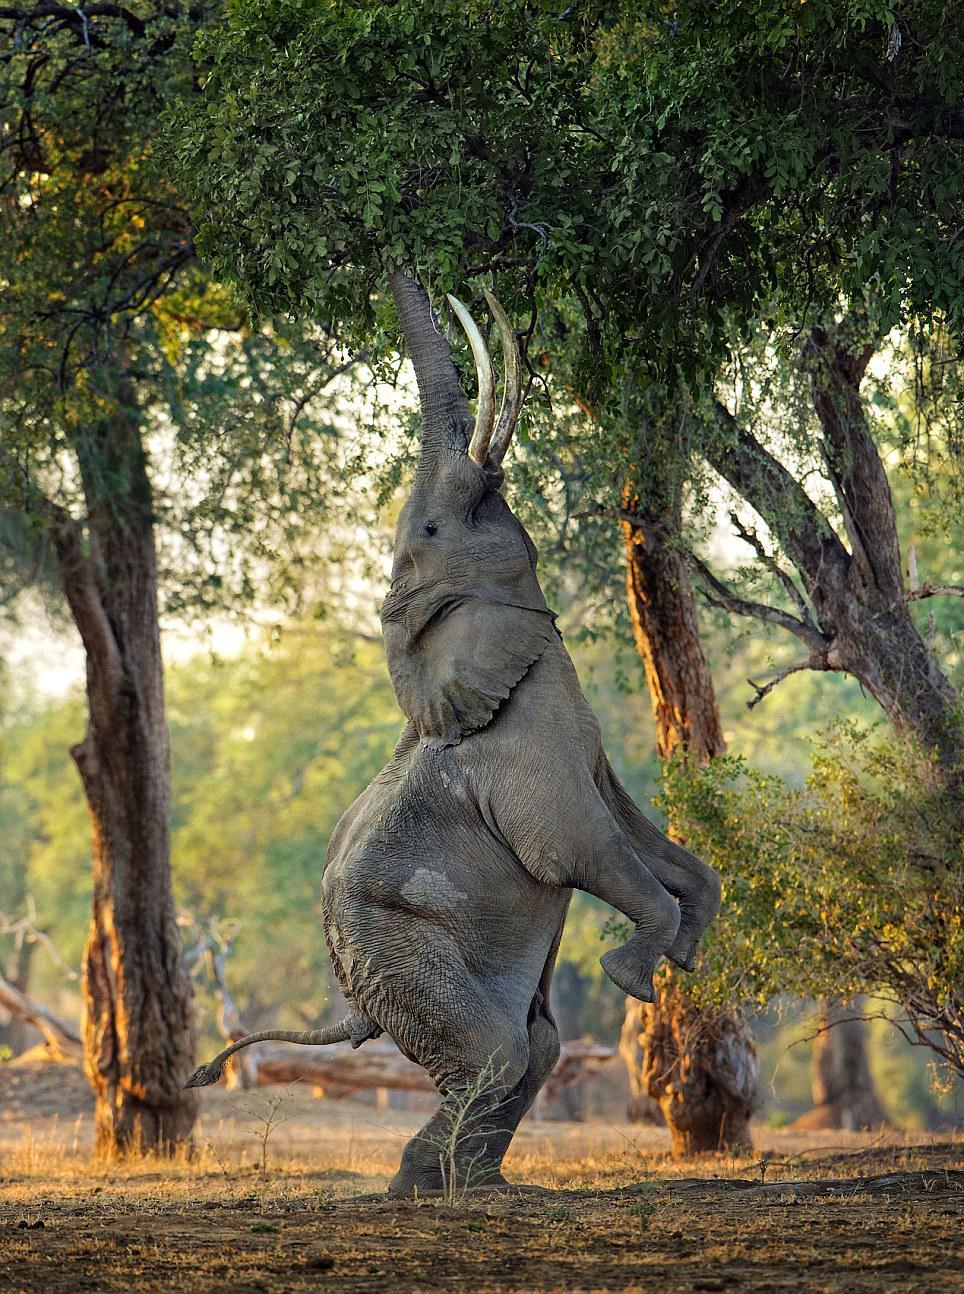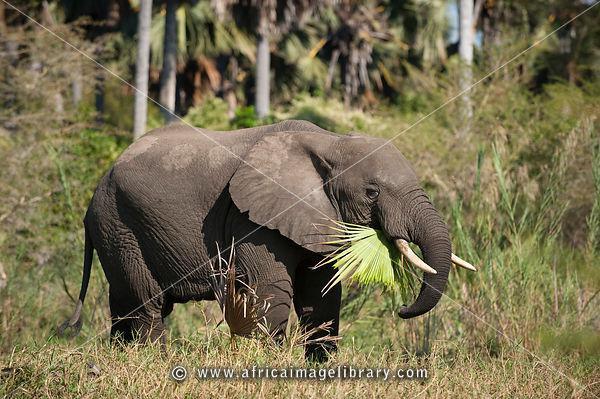The first image is the image on the left, the second image is the image on the right. Examine the images to the left and right. Is the description "One of the elephants is facing upwards." accurate? Answer yes or no. Yes. 